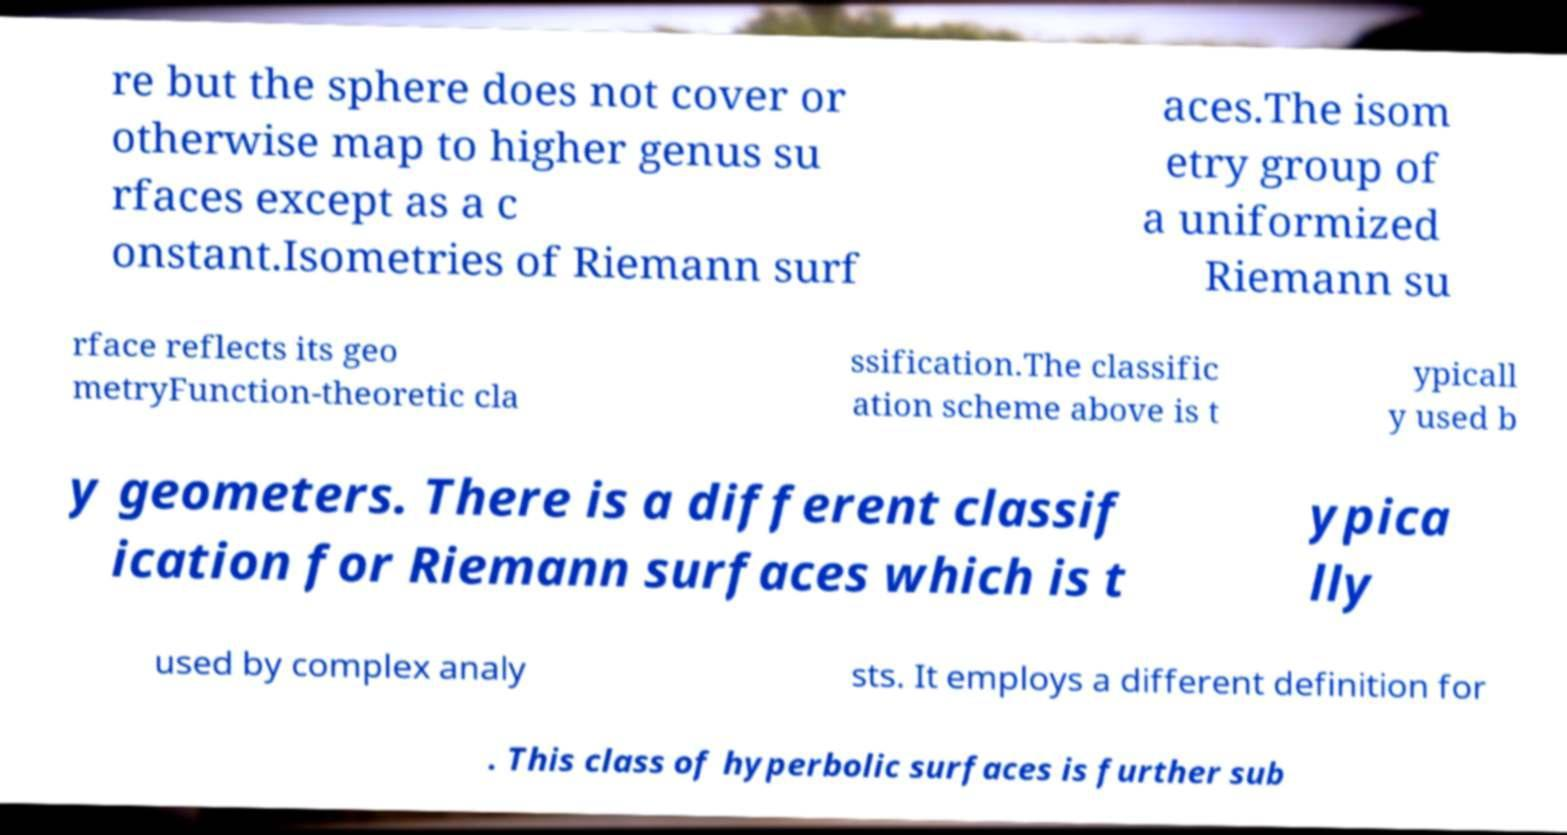Please identify and transcribe the text found in this image. re but the sphere does not cover or otherwise map to higher genus su rfaces except as a c onstant.Isometries of Riemann surf aces.The isom etry group of a uniformized Riemann su rface reflects its geo metryFunction-theoretic cla ssification.The classific ation scheme above is t ypicall y used b y geometers. There is a different classif ication for Riemann surfaces which is t ypica lly used by complex analy sts. It employs a different definition for . This class of hyperbolic surfaces is further sub 